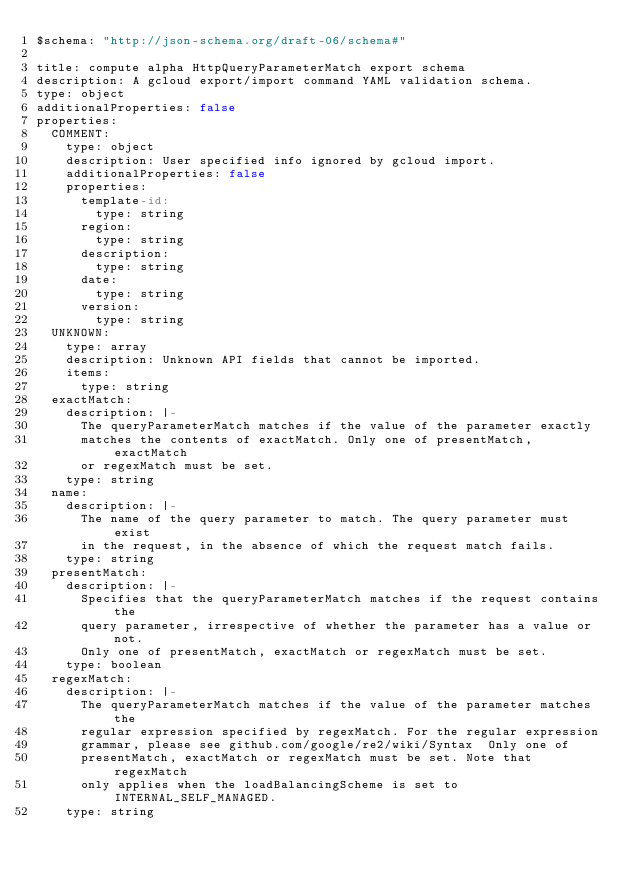Convert code to text. <code><loc_0><loc_0><loc_500><loc_500><_YAML_>$schema: "http://json-schema.org/draft-06/schema#"

title: compute alpha HttpQueryParameterMatch export schema
description: A gcloud export/import command YAML validation schema.
type: object
additionalProperties: false
properties:
  COMMENT:
    type: object
    description: User specified info ignored by gcloud import.
    additionalProperties: false
    properties:
      template-id:
        type: string
      region:
        type: string
      description:
        type: string
      date:
        type: string
      version:
        type: string
  UNKNOWN:
    type: array
    description: Unknown API fields that cannot be imported.
    items:
      type: string
  exactMatch:
    description: |-
      The queryParameterMatch matches if the value of the parameter exactly
      matches the contents of exactMatch. Only one of presentMatch, exactMatch
      or regexMatch must be set.
    type: string
  name:
    description: |-
      The name of the query parameter to match. The query parameter must exist
      in the request, in the absence of which the request match fails.
    type: string
  presentMatch:
    description: |-
      Specifies that the queryParameterMatch matches if the request contains the
      query parameter, irrespective of whether the parameter has a value or not.
      Only one of presentMatch, exactMatch or regexMatch must be set.
    type: boolean
  regexMatch:
    description: |-
      The queryParameterMatch matches if the value of the parameter matches the
      regular expression specified by regexMatch. For the regular expression
      grammar, please see github.com/google/re2/wiki/Syntax  Only one of
      presentMatch, exactMatch or regexMatch must be set. Note that regexMatch
      only applies when the loadBalancingScheme is set to INTERNAL_SELF_MANAGED.
    type: string
</code> 